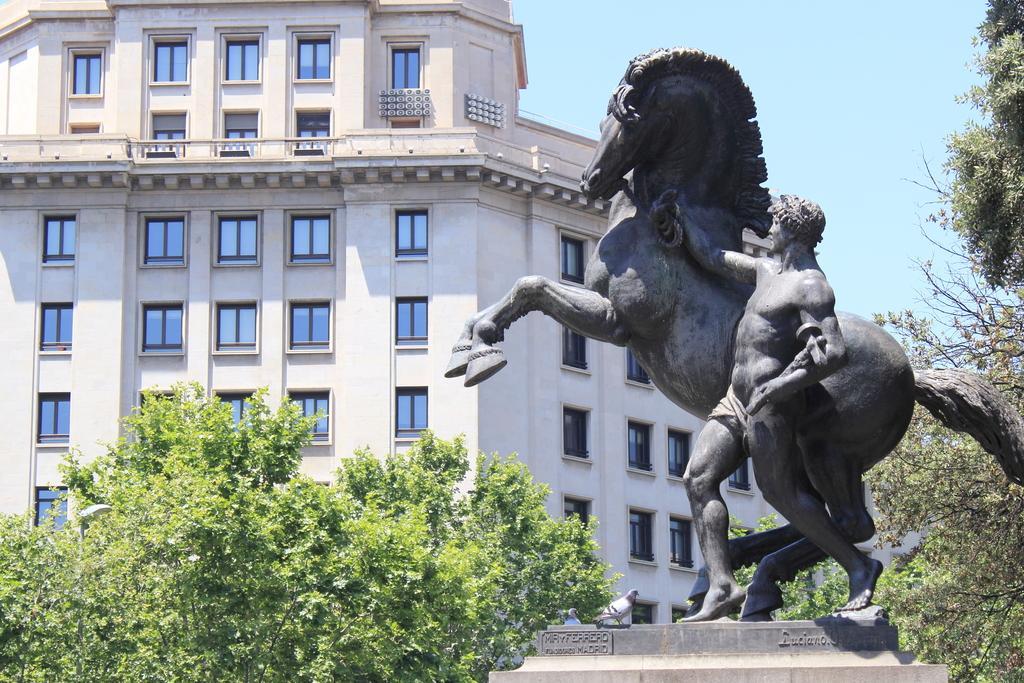Could you give a brief overview of what you see in this image? In this image I see a statue of a person and a horse. In the background I see the building , trees and the sky. 